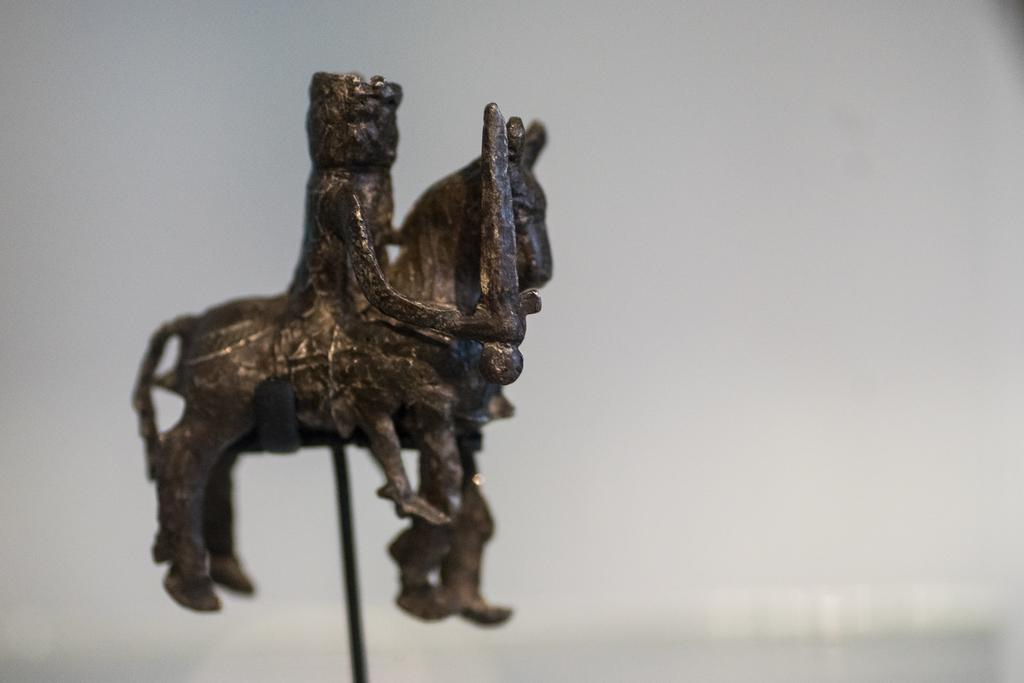What is the main subject of the image? There is a statue of a horse in the image. What else can be seen in the image? There is a person holding a sword in the image. What color is the background of the image? The background of the image is white in color. What type of sign can be seen in the image? There is no sign present in the image. What is the temperature of the horse in the image? The temperature of the horse cannot be determined from the image, as it is a statue made of a material that does not have a temperature. 